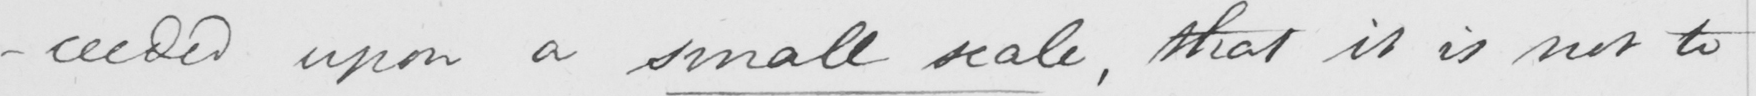Transcribe the text shown in this historical manuscript line. -ceeded upon a small scale , that it is not to 